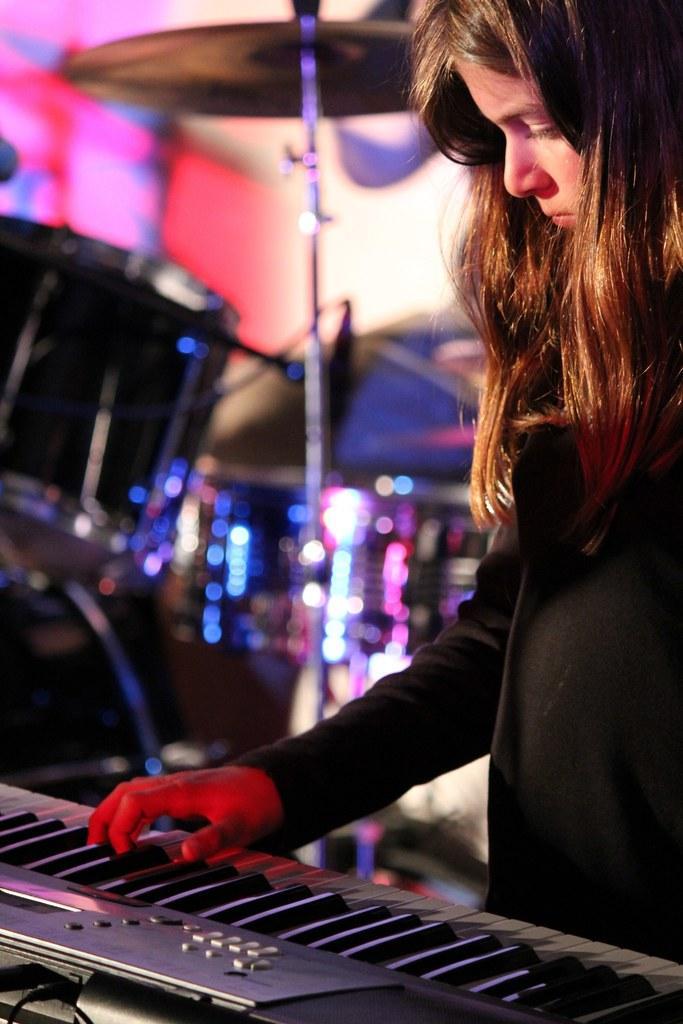In one or two sentences, can you explain what this image depicts? In this image I can see a girl, a musical keyboard and a drum set. 